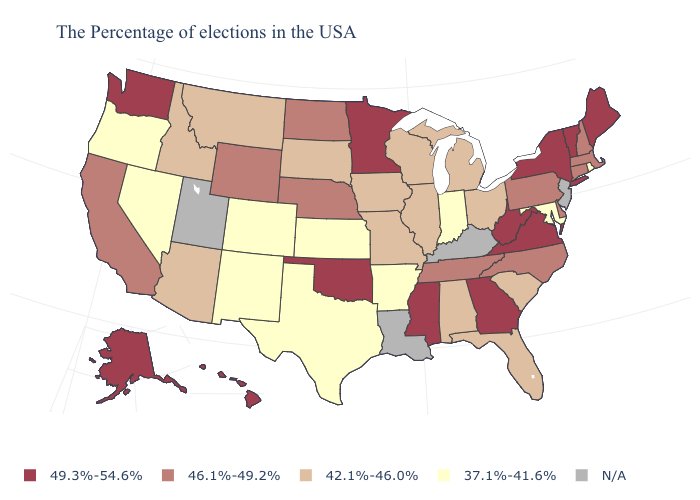What is the value of Hawaii?
Keep it brief. 49.3%-54.6%. What is the value of Maryland?
Short answer required. 37.1%-41.6%. How many symbols are there in the legend?
Write a very short answer. 5. Does Nebraska have the lowest value in the USA?
Write a very short answer. No. Name the states that have a value in the range 49.3%-54.6%?
Short answer required. Maine, Vermont, New York, Virginia, West Virginia, Georgia, Mississippi, Minnesota, Oklahoma, Washington, Alaska, Hawaii. Name the states that have a value in the range 46.1%-49.2%?
Quick response, please. Massachusetts, New Hampshire, Connecticut, Delaware, Pennsylvania, North Carolina, Tennessee, Nebraska, North Dakota, Wyoming, California. Does the first symbol in the legend represent the smallest category?
Keep it brief. No. Which states have the lowest value in the USA?
Quick response, please. Rhode Island, Maryland, Indiana, Arkansas, Kansas, Texas, Colorado, New Mexico, Nevada, Oregon. Does the map have missing data?
Short answer required. Yes. What is the highest value in states that border Delaware?
Concise answer only. 46.1%-49.2%. What is the value of New York?
Keep it brief. 49.3%-54.6%. Does the first symbol in the legend represent the smallest category?
Keep it brief. No. 